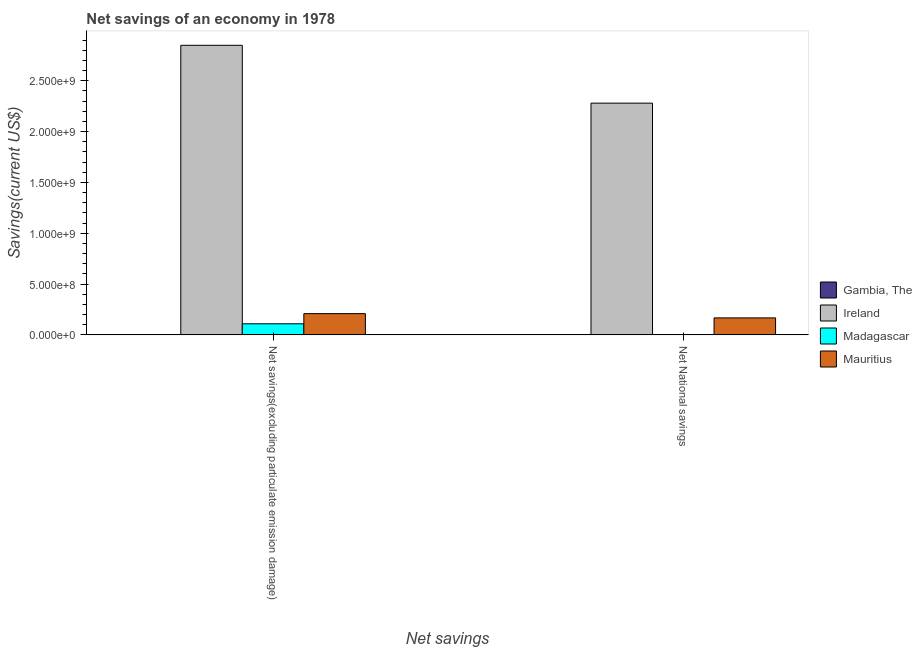How many groups of bars are there?
Give a very brief answer. 2. Are the number of bars on each tick of the X-axis equal?
Your response must be concise. Yes. How many bars are there on the 2nd tick from the left?
Provide a succinct answer. 3. How many bars are there on the 2nd tick from the right?
Make the answer very short. 3. What is the label of the 1st group of bars from the left?
Make the answer very short. Net savings(excluding particulate emission damage). What is the net national savings in Ireland?
Your answer should be compact. 2.28e+09. Across all countries, what is the maximum net savings(excluding particulate emission damage)?
Provide a short and direct response. 2.85e+09. Across all countries, what is the minimum net savings(excluding particulate emission damage)?
Your answer should be very brief. 0. In which country was the net savings(excluding particulate emission damage) maximum?
Give a very brief answer. Ireland. What is the total net national savings in the graph?
Keep it short and to the point. 2.45e+09. What is the difference between the net savings(excluding particulate emission damage) in Mauritius and that in Ireland?
Offer a very short reply. -2.64e+09. What is the difference between the net savings(excluding particulate emission damage) in Madagascar and the net national savings in Mauritius?
Ensure brevity in your answer.  -5.79e+07. What is the average net savings(excluding particulate emission damage) per country?
Offer a terse response. 7.92e+08. What is the difference between the net savings(excluding particulate emission damage) and net national savings in Mauritius?
Your answer should be very brief. 4.20e+07. What is the ratio of the net savings(excluding particulate emission damage) in Mauritius to that in Ireland?
Your answer should be very brief. 0.07. Is the net savings(excluding particulate emission damage) in Ireland less than that in Madagascar?
Offer a terse response. No. How many bars are there?
Your answer should be compact. 6. Are all the bars in the graph horizontal?
Offer a terse response. No. How many countries are there in the graph?
Provide a short and direct response. 4. Are the values on the major ticks of Y-axis written in scientific E-notation?
Offer a terse response. Yes. Where does the legend appear in the graph?
Offer a very short reply. Center right. How many legend labels are there?
Give a very brief answer. 4. How are the legend labels stacked?
Your answer should be compact. Vertical. What is the title of the graph?
Your answer should be very brief. Net savings of an economy in 1978. What is the label or title of the X-axis?
Offer a terse response. Net savings. What is the label or title of the Y-axis?
Provide a succinct answer. Savings(current US$). What is the Savings(current US$) in Gambia, The in Net savings(excluding particulate emission damage)?
Offer a very short reply. 0. What is the Savings(current US$) of Ireland in Net savings(excluding particulate emission damage)?
Your answer should be compact. 2.85e+09. What is the Savings(current US$) in Madagascar in Net savings(excluding particulate emission damage)?
Give a very brief answer. 1.09e+08. What is the Savings(current US$) in Mauritius in Net savings(excluding particulate emission damage)?
Give a very brief answer. 2.09e+08. What is the Savings(current US$) of Ireland in Net National savings?
Ensure brevity in your answer.  2.28e+09. What is the Savings(current US$) in Madagascar in Net National savings?
Your answer should be compact. 2.29e+06. What is the Savings(current US$) in Mauritius in Net National savings?
Offer a very short reply. 1.67e+08. Across all Net savings, what is the maximum Savings(current US$) of Ireland?
Ensure brevity in your answer.  2.85e+09. Across all Net savings, what is the maximum Savings(current US$) in Madagascar?
Ensure brevity in your answer.  1.09e+08. Across all Net savings, what is the maximum Savings(current US$) of Mauritius?
Give a very brief answer. 2.09e+08. Across all Net savings, what is the minimum Savings(current US$) in Ireland?
Keep it short and to the point. 2.28e+09. Across all Net savings, what is the minimum Savings(current US$) of Madagascar?
Offer a terse response. 2.29e+06. Across all Net savings, what is the minimum Savings(current US$) in Mauritius?
Give a very brief answer. 1.67e+08. What is the total Savings(current US$) in Gambia, The in the graph?
Give a very brief answer. 0. What is the total Savings(current US$) of Ireland in the graph?
Make the answer very short. 5.13e+09. What is the total Savings(current US$) in Madagascar in the graph?
Ensure brevity in your answer.  1.12e+08. What is the total Savings(current US$) in Mauritius in the graph?
Your response must be concise. 3.76e+08. What is the difference between the Savings(current US$) of Ireland in Net savings(excluding particulate emission damage) and that in Net National savings?
Keep it short and to the point. 5.69e+08. What is the difference between the Savings(current US$) in Madagascar in Net savings(excluding particulate emission damage) and that in Net National savings?
Keep it short and to the point. 1.07e+08. What is the difference between the Savings(current US$) of Mauritius in Net savings(excluding particulate emission damage) and that in Net National savings?
Offer a terse response. 4.20e+07. What is the difference between the Savings(current US$) of Ireland in Net savings(excluding particulate emission damage) and the Savings(current US$) of Madagascar in Net National savings?
Provide a short and direct response. 2.85e+09. What is the difference between the Savings(current US$) in Ireland in Net savings(excluding particulate emission damage) and the Savings(current US$) in Mauritius in Net National savings?
Offer a terse response. 2.68e+09. What is the difference between the Savings(current US$) in Madagascar in Net savings(excluding particulate emission damage) and the Savings(current US$) in Mauritius in Net National savings?
Your answer should be very brief. -5.79e+07. What is the average Savings(current US$) of Ireland per Net savings?
Your response must be concise. 2.56e+09. What is the average Savings(current US$) of Madagascar per Net savings?
Your answer should be very brief. 5.58e+07. What is the average Savings(current US$) in Mauritius per Net savings?
Offer a very short reply. 1.88e+08. What is the difference between the Savings(current US$) in Ireland and Savings(current US$) in Madagascar in Net savings(excluding particulate emission damage)?
Provide a succinct answer. 2.74e+09. What is the difference between the Savings(current US$) of Ireland and Savings(current US$) of Mauritius in Net savings(excluding particulate emission damage)?
Make the answer very short. 2.64e+09. What is the difference between the Savings(current US$) in Madagascar and Savings(current US$) in Mauritius in Net savings(excluding particulate emission damage)?
Provide a short and direct response. -9.99e+07. What is the difference between the Savings(current US$) of Ireland and Savings(current US$) of Madagascar in Net National savings?
Your response must be concise. 2.28e+09. What is the difference between the Savings(current US$) of Ireland and Savings(current US$) of Mauritius in Net National savings?
Provide a short and direct response. 2.11e+09. What is the difference between the Savings(current US$) in Madagascar and Savings(current US$) in Mauritius in Net National savings?
Your answer should be very brief. -1.65e+08. What is the ratio of the Savings(current US$) of Ireland in Net savings(excluding particulate emission damage) to that in Net National savings?
Offer a very short reply. 1.25. What is the ratio of the Savings(current US$) in Madagascar in Net savings(excluding particulate emission damage) to that in Net National savings?
Offer a terse response. 47.78. What is the ratio of the Savings(current US$) in Mauritius in Net savings(excluding particulate emission damage) to that in Net National savings?
Offer a very short reply. 1.25. What is the difference between the highest and the second highest Savings(current US$) in Ireland?
Your answer should be very brief. 5.69e+08. What is the difference between the highest and the second highest Savings(current US$) of Madagascar?
Make the answer very short. 1.07e+08. What is the difference between the highest and the second highest Savings(current US$) of Mauritius?
Keep it short and to the point. 4.20e+07. What is the difference between the highest and the lowest Savings(current US$) in Ireland?
Offer a very short reply. 5.69e+08. What is the difference between the highest and the lowest Savings(current US$) in Madagascar?
Keep it short and to the point. 1.07e+08. What is the difference between the highest and the lowest Savings(current US$) of Mauritius?
Offer a terse response. 4.20e+07. 